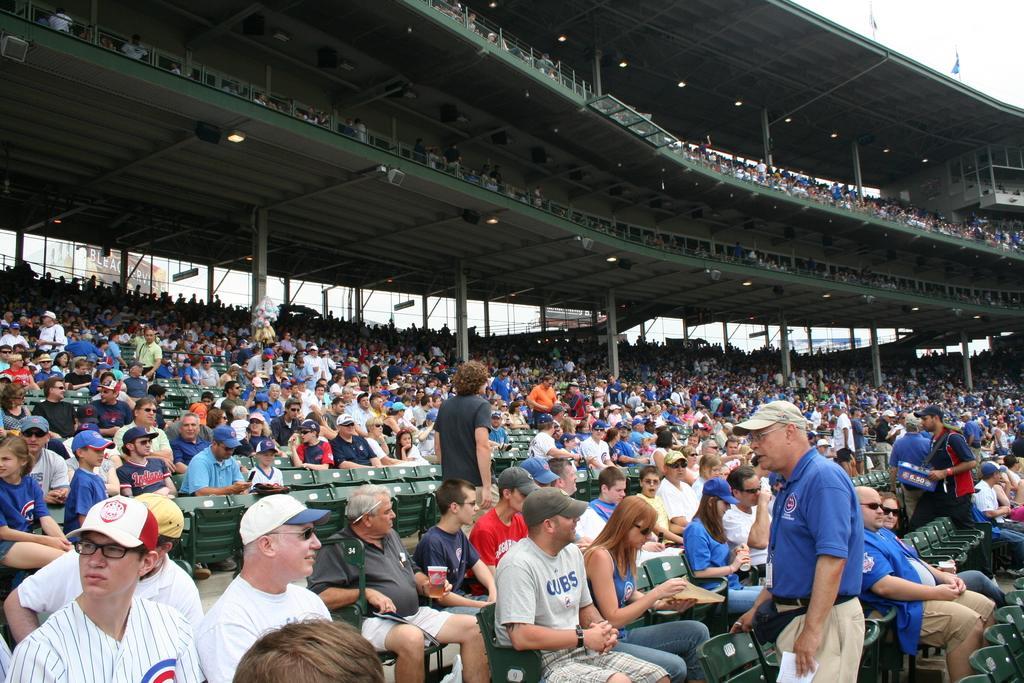In one or two sentences, can you explain what this image depicts? Here there are audience sitting on the chairs and among them few are standing and on the right there is a man holding a box in his hands. In the background there are poles,few person on the floors,hoardings and the sky. 